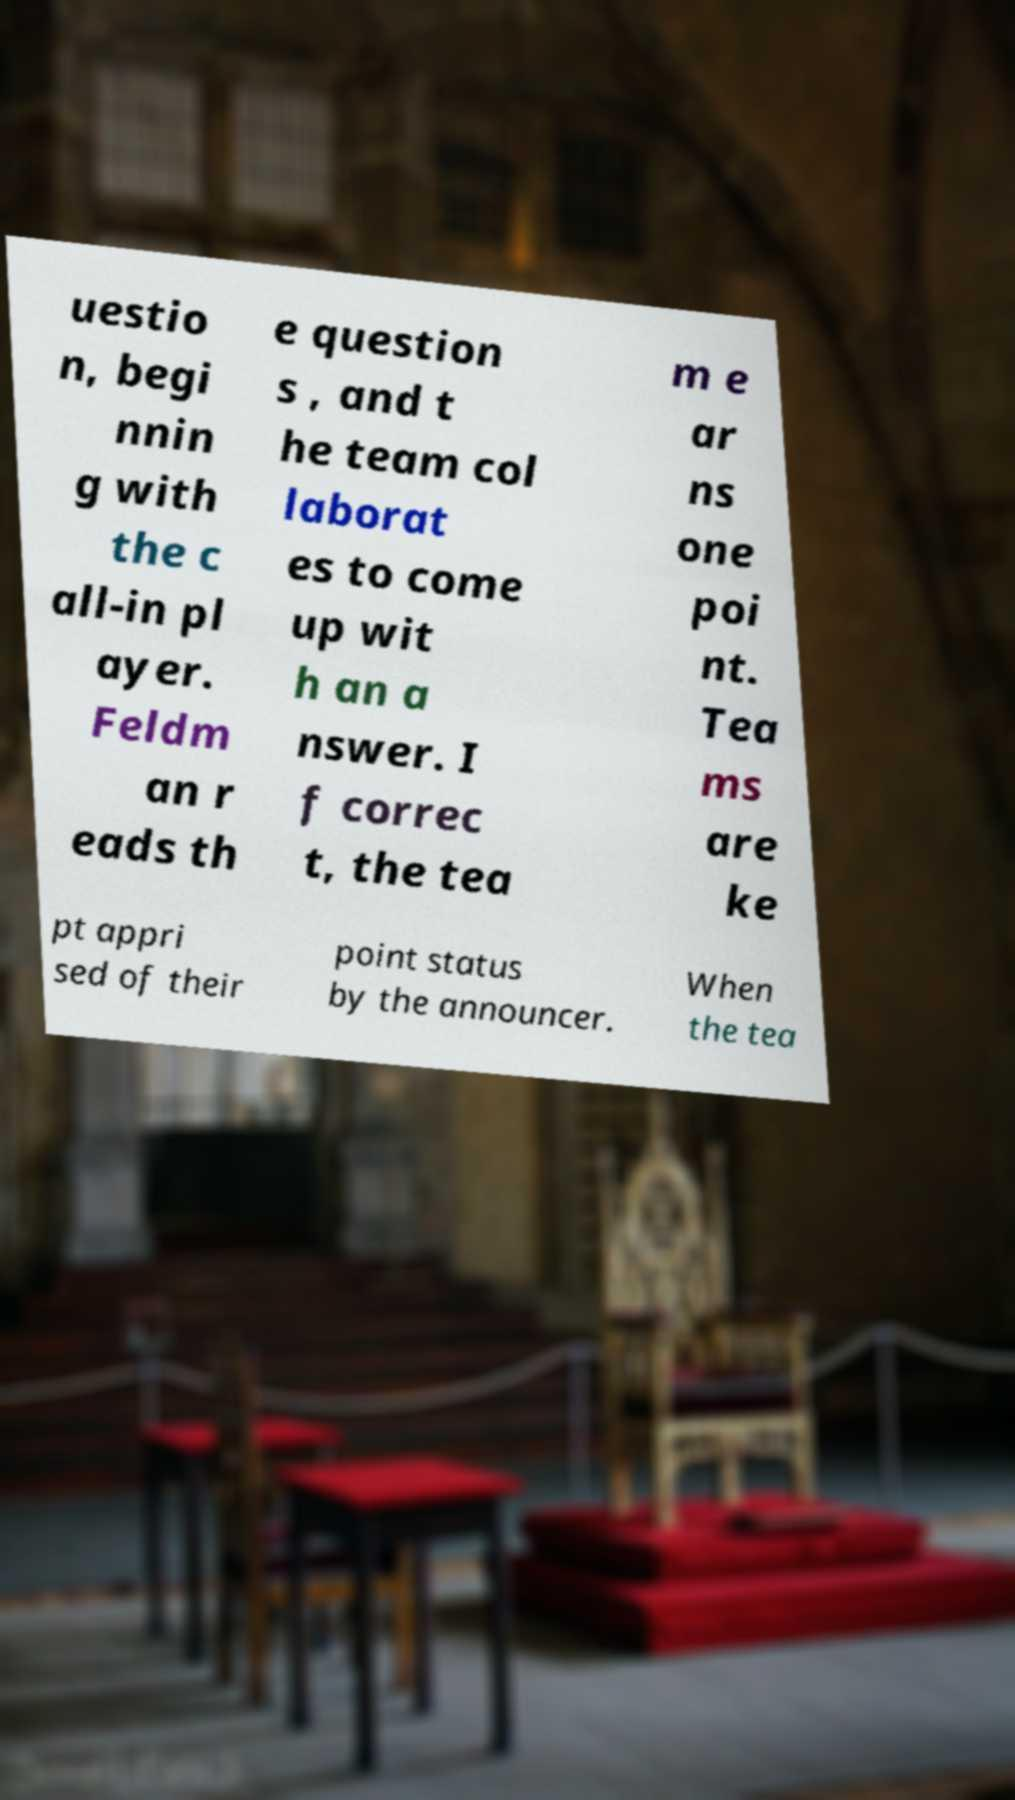Can you accurately transcribe the text from the provided image for me? uestio n, begi nnin g with the c all-in pl ayer. Feldm an r eads th e question s , and t he team col laborat es to come up wit h an a nswer. I f correc t, the tea m e ar ns one poi nt. Tea ms are ke pt appri sed of their point status by the announcer. When the tea 